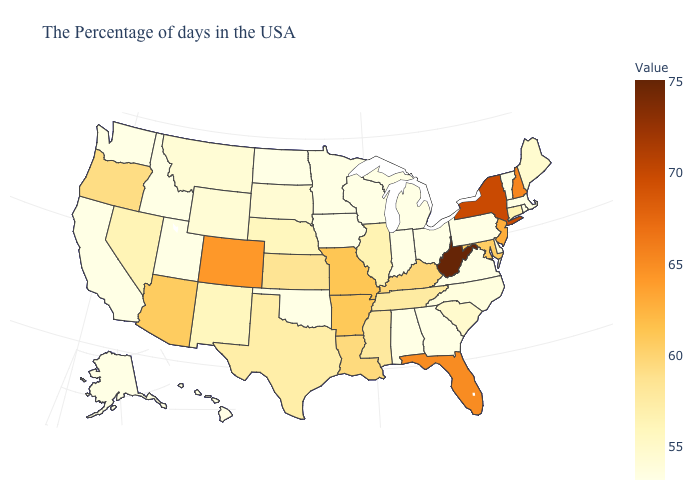Does the map have missing data?
Short answer required. No. Does the map have missing data?
Write a very short answer. No. Among the states that border Pennsylvania , which have the highest value?
Quick response, please. West Virginia. Among the states that border Colorado , does Wyoming have the lowest value?
Short answer required. No. Among the states that border Louisiana , which have the lowest value?
Short answer required. Texas. 